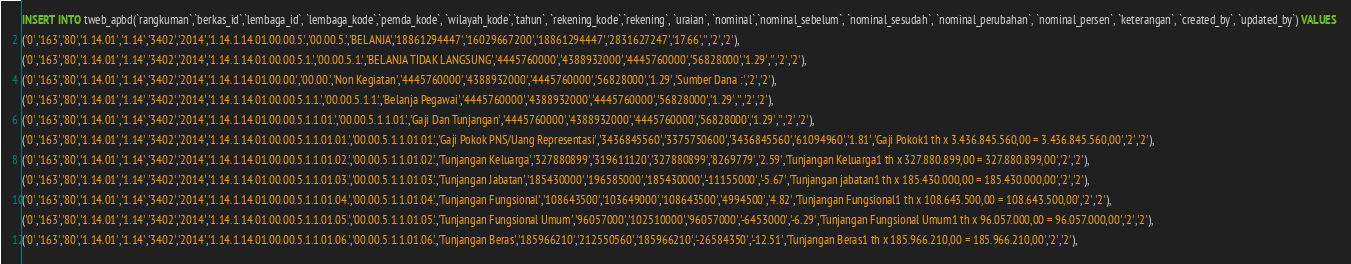<code> <loc_0><loc_0><loc_500><loc_500><_SQL_>INSERT INTO tweb_apbd(`rangkuman`,`berkas_id`,`lembaga_id`, `lembaga_kode`,`pemda_kode`, `wilayah_kode`,`tahun`, `rekening_kode`,`rekening`, `uraian`, `nominal`,`nominal_sebelum`, `nominal_sesudah`, `nominal_perubahan`, `nominal_persen`, `keterangan`, `created_by`, `updated_by`) VALUES 
('0','163','80','1.14.01','1.14','3402','2014','1.14.1.14.01.00.00.5.','00.00.5.','BELANJA','18861294447','16029667200','18861294447','2831627247','17.66','','2','2'),
('0','163','80','1.14.01','1.14','3402','2014','1.14.1.14.01.00.00.5.1.','00.00.5.1.','BELANJA TIDAK LANGSUNG','4445760000','4388932000','4445760000','56828000','1.29','','2','2'),
('0','163','80','1.14.01','1.14','3402','2014','1.14.1.14.01.00.00.','00.00.','Non Kegiatan','4445760000','4388932000','4445760000','56828000','1.29','Sumber Dana :','2','2'),
('0','163','80','1.14.01','1.14','3402','2014','1.14.1.14.01.00.00.5.1.1.','00.00.5.1.1.','Belanja Pegawai','4445760000','4388932000','4445760000','56828000','1.29','','2','2'),
('0','163','80','1.14.01','1.14','3402','2014','1.14.1.14.01.00.00.5.1.1.01.','00.00.5.1.1.01.','Gaji Dan Tunjangan','4445760000','4388932000','4445760000','56828000','1.29','','2','2'),
('0','163','80','1.14.01','1.14','3402','2014','1.14.1.14.01.00.00.5.1.1.01.01.','00.00.5.1.1.01.01.','Gaji Pokok PNS/Uang Representasi','3436845560','3375750600','3436845560','61094960','1.81','Gaji Pokok1 th x 3.436.845.560,00 = 3.436.845.560,00','2','2'),
('0','163','80','1.14.01','1.14','3402','2014','1.14.1.14.01.00.00.5.1.1.01.02.','00.00.5.1.1.01.02.','Tunjangan Keluarga','327880899','319611120','327880899','8269779','2.59','Tunjangan Keluarga1 th x 327.880.899,00 = 327.880.899,00','2','2'),
('0','163','80','1.14.01','1.14','3402','2014','1.14.1.14.01.00.00.5.1.1.01.03.','00.00.5.1.1.01.03.','Tunjangan Jabatan','185430000','196585000','185430000','-11155000','-5.67','Tunjangan jabatan1 th x 185.430.000,00 = 185.430.000,00','2','2'),
('0','163','80','1.14.01','1.14','3402','2014','1.14.1.14.01.00.00.5.1.1.01.04.','00.00.5.1.1.01.04.','Tunjangan Fungsional','108643500','103649000','108643500','4994500','4.82','Tunjangan Fungsional1 th x 108.643.500,00 = 108.643.500,00','2','2'),
('0','163','80','1.14.01','1.14','3402','2014','1.14.1.14.01.00.00.5.1.1.01.05.','00.00.5.1.1.01.05.','Tunjangan Fungsional Umum','96057000','102510000','96057000','-6453000','-6.29','Tunjangan Fungsional Umum1 th x 96.057.000,00 = 96.057.000,00','2','2'),
('0','163','80','1.14.01','1.14','3402','2014','1.14.1.14.01.00.00.5.1.1.01.06.','00.00.5.1.1.01.06.','Tunjangan Beras','185966210','212550560','185966210','-26584350','-12.51','Tunjangan Beras1 th x 185.966.210,00 = 185.966.210,00','2','2'),</code> 